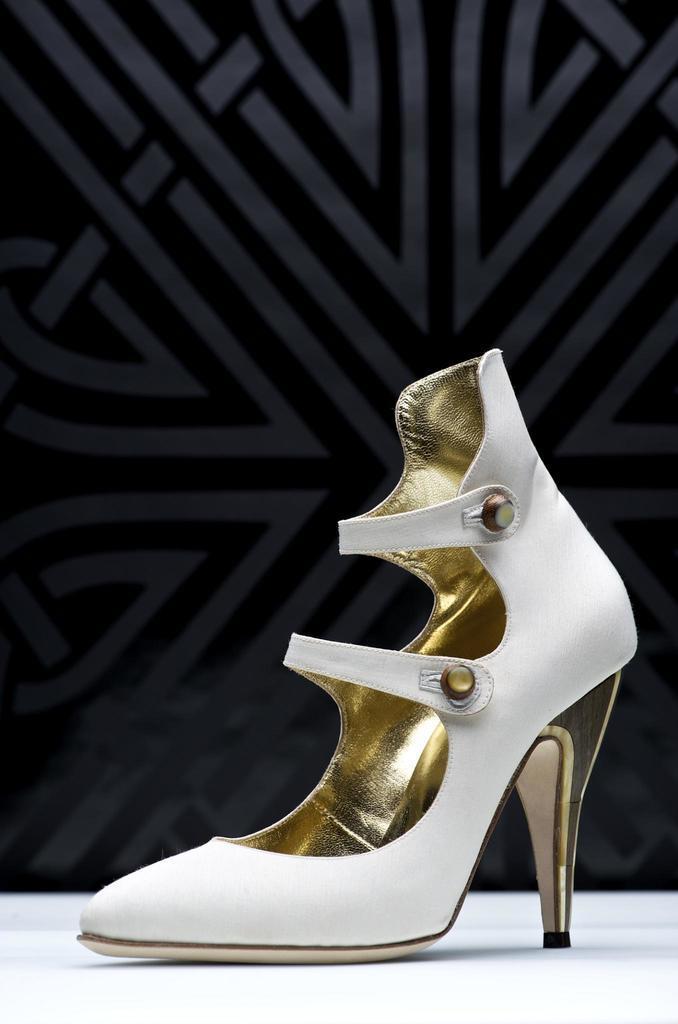Could you give a brief overview of what you see in this image? In this image I can see white colour surface and on it I can see a white and golden colour heel. 